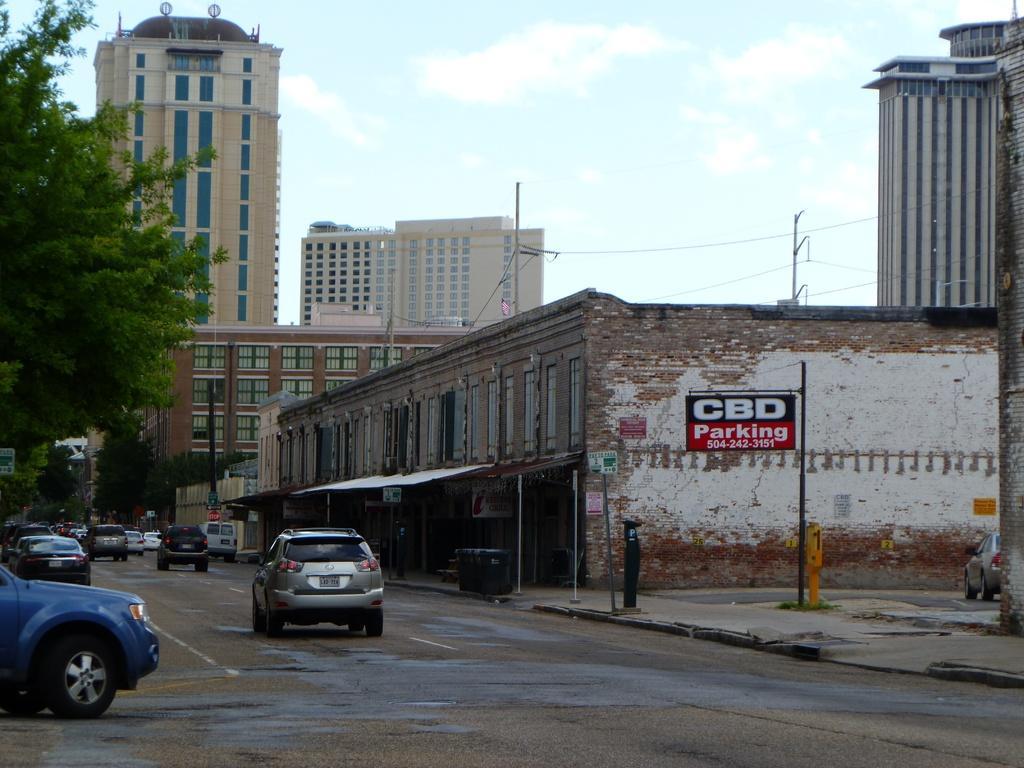Please provide a concise description of this image. This picture is clicked outside. On the left we can see the group of vehicles running on the road and we can see the trees. On the right there is a board attached to the pole and the text is printed on the board and there are some objects on the ground. In the background there is a sky, buildings, cables and the cars. 